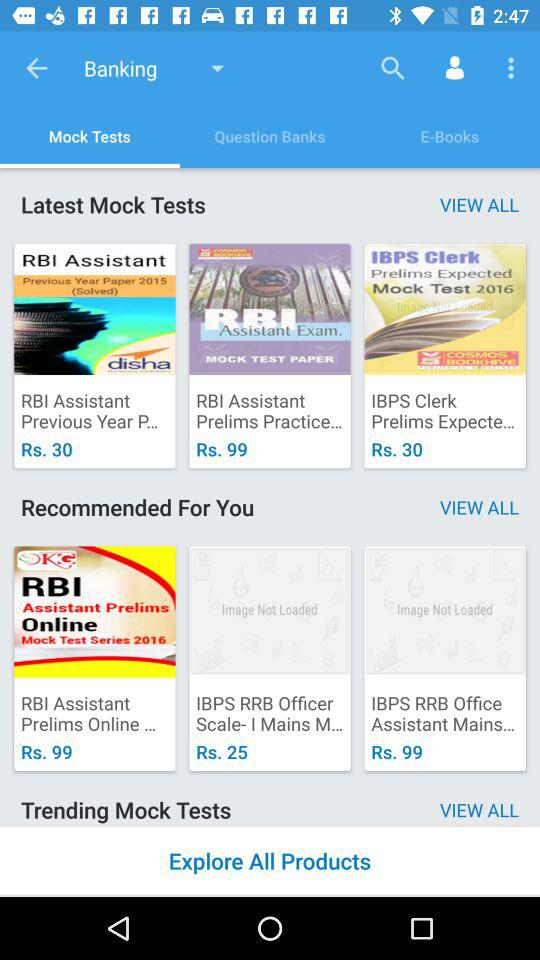Which option is selected in banking? The selected option is "Mock Tests". 